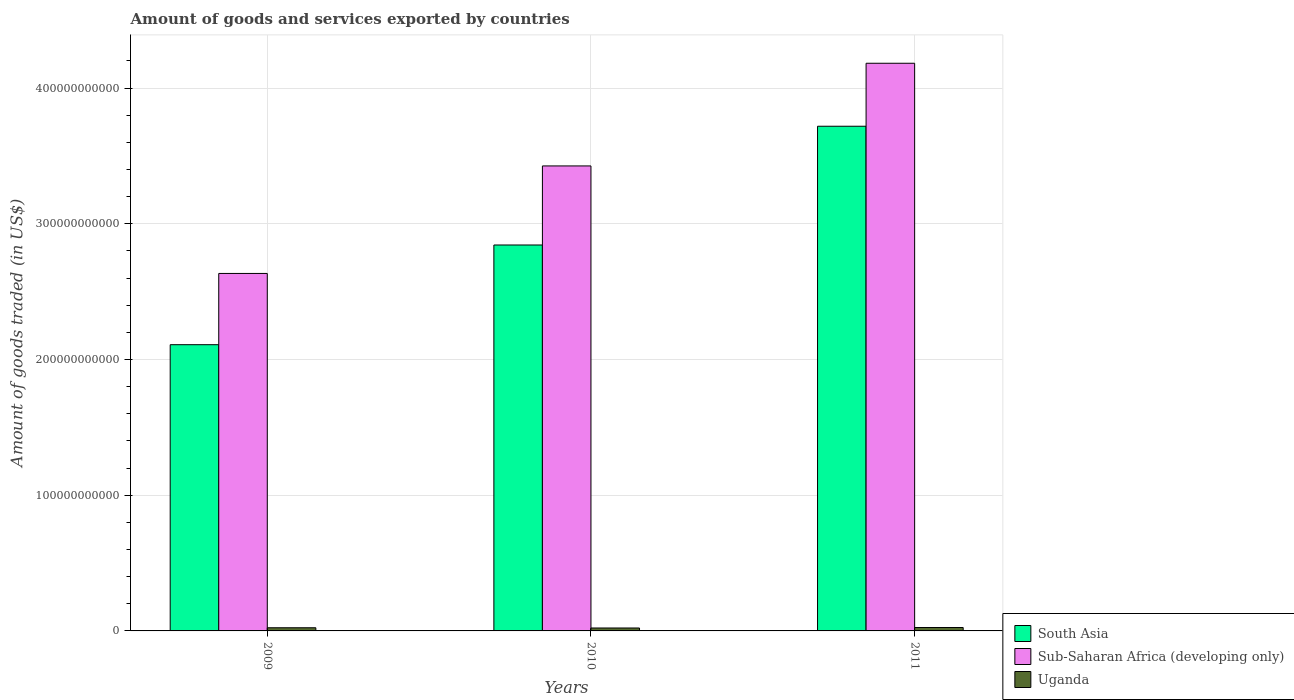How many groups of bars are there?
Ensure brevity in your answer.  3. Are the number of bars per tick equal to the number of legend labels?
Your answer should be compact. Yes. Are the number of bars on each tick of the X-axis equal?
Your response must be concise. Yes. How many bars are there on the 2nd tick from the right?
Keep it short and to the point. 3. What is the label of the 2nd group of bars from the left?
Give a very brief answer. 2010. What is the total amount of goods and services exported in South Asia in 2011?
Your answer should be compact. 3.72e+11. Across all years, what is the maximum total amount of goods and services exported in Sub-Saharan Africa (developing only)?
Your answer should be very brief. 4.18e+11. Across all years, what is the minimum total amount of goods and services exported in Uganda?
Provide a succinct answer. 2.16e+09. In which year was the total amount of goods and services exported in Sub-Saharan Africa (developing only) maximum?
Provide a succinct answer. 2011. What is the total total amount of goods and services exported in Sub-Saharan Africa (developing only) in the graph?
Your answer should be very brief. 1.02e+12. What is the difference between the total amount of goods and services exported in Uganda in 2009 and that in 2010?
Provide a succinct answer. 1.63e+08. What is the difference between the total amount of goods and services exported in South Asia in 2011 and the total amount of goods and services exported in Uganda in 2010?
Keep it short and to the point. 3.70e+11. What is the average total amount of goods and services exported in Sub-Saharan Africa (developing only) per year?
Offer a terse response. 3.41e+11. In the year 2010, what is the difference between the total amount of goods and services exported in Sub-Saharan Africa (developing only) and total amount of goods and services exported in South Asia?
Provide a succinct answer. 5.83e+1. What is the ratio of the total amount of goods and services exported in Uganda in 2009 to that in 2011?
Your response must be concise. 0.92. Is the difference between the total amount of goods and services exported in Sub-Saharan Africa (developing only) in 2009 and 2010 greater than the difference between the total amount of goods and services exported in South Asia in 2009 and 2010?
Keep it short and to the point. No. What is the difference between the highest and the second highest total amount of goods and services exported in South Asia?
Provide a short and direct response. 8.75e+1. What is the difference between the highest and the lowest total amount of goods and services exported in Uganda?
Offer a very short reply. 3.55e+08. What does the 3rd bar from the left in 2010 represents?
Your answer should be compact. Uganda. What does the 1st bar from the right in 2011 represents?
Offer a terse response. Uganda. How many years are there in the graph?
Offer a terse response. 3. What is the difference between two consecutive major ticks on the Y-axis?
Give a very brief answer. 1.00e+11. Are the values on the major ticks of Y-axis written in scientific E-notation?
Provide a succinct answer. No. Does the graph contain any zero values?
Make the answer very short. No. How many legend labels are there?
Your response must be concise. 3. How are the legend labels stacked?
Provide a short and direct response. Vertical. What is the title of the graph?
Your response must be concise. Amount of goods and services exported by countries. What is the label or title of the X-axis?
Ensure brevity in your answer.  Years. What is the label or title of the Y-axis?
Give a very brief answer. Amount of goods traded (in US$). What is the Amount of goods traded (in US$) of South Asia in 2009?
Make the answer very short. 2.11e+11. What is the Amount of goods traded (in US$) of Sub-Saharan Africa (developing only) in 2009?
Your answer should be very brief. 2.63e+11. What is the Amount of goods traded (in US$) of Uganda in 2009?
Your response must be concise. 2.33e+09. What is the Amount of goods traded (in US$) in South Asia in 2010?
Your answer should be very brief. 2.84e+11. What is the Amount of goods traded (in US$) in Sub-Saharan Africa (developing only) in 2010?
Your response must be concise. 3.43e+11. What is the Amount of goods traded (in US$) of Uganda in 2010?
Provide a short and direct response. 2.16e+09. What is the Amount of goods traded (in US$) in South Asia in 2011?
Offer a terse response. 3.72e+11. What is the Amount of goods traded (in US$) in Sub-Saharan Africa (developing only) in 2011?
Offer a very short reply. 4.18e+11. What is the Amount of goods traded (in US$) in Uganda in 2011?
Offer a terse response. 2.52e+09. Across all years, what is the maximum Amount of goods traded (in US$) in South Asia?
Ensure brevity in your answer.  3.72e+11. Across all years, what is the maximum Amount of goods traded (in US$) of Sub-Saharan Africa (developing only)?
Provide a short and direct response. 4.18e+11. Across all years, what is the maximum Amount of goods traded (in US$) of Uganda?
Your response must be concise. 2.52e+09. Across all years, what is the minimum Amount of goods traded (in US$) of South Asia?
Make the answer very short. 2.11e+11. Across all years, what is the minimum Amount of goods traded (in US$) in Sub-Saharan Africa (developing only)?
Your answer should be very brief. 2.63e+11. Across all years, what is the minimum Amount of goods traded (in US$) in Uganda?
Provide a succinct answer. 2.16e+09. What is the total Amount of goods traded (in US$) of South Asia in the graph?
Give a very brief answer. 8.67e+11. What is the total Amount of goods traded (in US$) of Sub-Saharan Africa (developing only) in the graph?
Your response must be concise. 1.02e+12. What is the total Amount of goods traded (in US$) of Uganda in the graph?
Your answer should be very brief. 7.01e+09. What is the difference between the Amount of goods traded (in US$) in South Asia in 2009 and that in 2010?
Your answer should be compact. -7.35e+1. What is the difference between the Amount of goods traded (in US$) in Sub-Saharan Africa (developing only) in 2009 and that in 2010?
Provide a short and direct response. -7.92e+1. What is the difference between the Amount of goods traded (in US$) in Uganda in 2009 and that in 2010?
Ensure brevity in your answer.  1.63e+08. What is the difference between the Amount of goods traded (in US$) of South Asia in 2009 and that in 2011?
Keep it short and to the point. -1.61e+11. What is the difference between the Amount of goods traded (in US$) of Sub-Saharan Africa (developing only) in 2009 and that in 2011?
Give a very brief answer. -1.55e+11. What is the difference between the Amount of goods traded (in US$) in Uganda in 2009 and that in 2011?
Offer a very short reply. -1.93e+08. What is the difference between the Amount of goods traded (in US$) of South Asia in 2010 and that in 2011?
Ensure brevity in your answer.  -8.75e+1. What is the difference between the Amount of goods traded (in US$) of Sub-Saharan Africa (developing only) in 2010 and that in 2011?
Offer a terse response. -7.57e+1. What is the difference between the Amount of goods traded (in US$) in Uganda in 2010 and that in 2011?
Offer a very short reply. -3.55e+08. What is the difference between the Amount of goods traded (in US$) in South Asia in 2009 and the Amount of goods traded (in US$) in Sub-Saharan Africa (developing only) in 2010?
Your answer should be very brief. -1.32e+11. What is the difference between the Amount of goods traded (in US$) of South Asia in 2009 and the Amount of goods traded (in US$) of Uganda in 2010?
Offer a very short reply. 2.09e+11. What is the difference between the Amount of goods traded (in US$) in Sub-Saharan Africa (developing only) in 2009 and the Amount of goods traded (in US$) in Uganda in 2010?
Provide a succinct answer. 2.61e+11. What is the difference between the Amount of goods traded (in US$) of South Asia in 2009 and the Amount of goods traded (in US$) of Sub-Saharan Africa (developing only) in 2011?
Your answer should be compact. -2.07e+11. What is the difference between the Amount of goods traded (in US$) in South Asia in 2009 and the Amount of goods traded (in US$) in Uganda in 2011?
Your response must be concise. 2.08e+11. What is the difference between the Amount of goods traded (in US$) in Sub-Saharan Africa (developing only) in 2009 and the Amount of goods traded (in US$) in Uganda in 2011?
Provide a short and direct response. 2.61e+11. What is the difference between the Amount of goods traded (in US$) of South Asia in 2010 and the Amount of goods traded (in US$) of Sub-Saharan Africa (developing only) in 2011?
Offer a very short reply. -1.34e+11. What is the difference between the Amount of goods traded (in US$) of South Asia in 2010 and the Amount of goods traded (in US$) of Uganda in 2011?
Provide a succinct answer. 2.82e+11. What is the difference between the Amount of goods traded (in US$) of Sub-Saharan Africa (developing only) in 2010 and the Amount of goods traded (in US$) of Uganda in 2011?
Give a very brief answer. 3.40e+11. What is the average Amount of goods traded (in US$) of South Asia per year?
Your response must be concise. 2.89e+11. What is the average Amount of goods traded (in US$) in Sub-Saharan Africa (developing only) per year?
Offer a terse response. 3.41e+11. What is the average Amount of goods traded (in US$) of Uganda per year?
Provide a succinct answer. 2.34e+09. In the year 2009, what is the difference between the Amount of goods traded (in US$) of South Asia and Amount of goods traded (in US$) of Sub-Saharan Africa (developing only)?
Provide a short and direct response. -5.25e+1. In the year 2009, what is the difference between the Amount of goods traded (in US$) in South Asia and Amount of goods traded (in US$) in Uganda?
Make the answer very short. 2.09e+11. In the year 2009, what is the difference between the Amount of goods traded (in US$) of Sub-Saharan Africa (developing only) and Amount of goods traded (in US$) of Uganda?
Keep it short and to the point. 2.61e+11. In the year 2010, what is the difference between the Amount of goods traded (in US$) in South Asia and Amount of goods traded (in US$) in Sub-Saharan Africa (developing only)?
Offer a very short reply. -5.83e+1. In the year 2010, what is the difference between the Amount of goods traded (in US$) of South Asia and Amount of goods traded (in US$) of Uganda?
Ensure brevity in your answer.  2.82e+11. In the year 2010, what is the difference between the Amount of goods traded (in US$) of Sub-Saharan Africa (developing only) and Amount of goods traded (in US$) of Uganda?
Provide a succinct answer. 3.41e+11. In the year 2011, what is the difference between the Amount of goods traded (in US$) in South Asia and Amount of goods traded (in US$) in Sub-Saharan Africa (developing only)?
Your response must be concise. -4.64e+1. In the year 2011, what is the difference between the Amount of goods traded (in US$) in South Asia and Amount of goods traded (in US$) in Uganda?
Your response must be concise. 3.69e+11. In the year 2011, what is the difference between the Amount of goods traded (in US$) in Sub-Saharan Africa (developing only) and Amount of goods traded (in US$) in Uganda?
Your answer should be very brief. 4.16e+11. What is the ratio of the Amount of goods traded (in US$) of South Asia in 2009 to that in 2010?
Provide a short and direct response. 0.74. What is the ratio of the Amount of goods traded (in US$) of Sub-Saharan Africa (developing only) in 2009 to that in 2010?
Your answer should be compact. 0.77. What is the ratio of the Amount of goods traded (in US$) in Uganda in 2009 to that in 2010?
Provide a succinct answer. 1.08. What is the ratio of the Amount of goods traded (in US$) in South Asia in 2009 to that in 2011?
Your answer should be compact. 0.57. What is the ratio of the Amount of goods traded (in US$) in Sub-Saharan Africa (developing only) in 2009 to that in 2011?
Make the answer very short. 0.63. What is the ratio of the Amount of goods traded (in US$) in Uganda in 2009 to that in 2011?
Provide a succinct answer. 0.92. What is the ratio of the Amount of goods traded (in US$) in South Asia in 2010 to that in 2011?
Offer a very short reply. 0.76. What is the ratio of the Amount of goods traded (in US$) in Sub-Saharan Africa (developing only) in 2010 to that in 2011?
Offer a terse response. 0.82. What is the ratio of the Amount of goods traded (in US$) in Uganda in 2010 to that in 2011?
Your response must be concise. 0.86. What is the difference between the highest and the second highest Amount of goods traded (in US$) in South Asia?
Keep it short and to the point. 8.75e+1. What is the difference between the highest and the second highest Amount of goods traded (in US$) in Sub-Saharan Africa (developing only)?
Keep it short and to the point. 7.57e+1. What is the difference between the highest and the second highest Amount of goods traded (in US$) of Uganda?
Your answer should be compact. 1.93e+08. What is the difference between the highest and the lowest Amount of goods traded (in US$) of South Asia?
Your response must be concise. 1.61e+11. What is the difference between the highest and the lowest Amount of goods traded (in US$) in Sub-Saharan Africa (developing only)?
Ensure brevity in your answer.  1.55e+11. What is the difference between the highest and the lowest Amount of goods traded (in US$) of Uganda?
Offer a very short reply. 3.55e+08. 